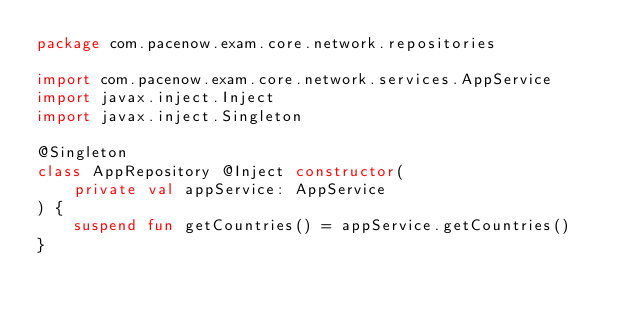Convert code to text. <code><loc_0><loc_0><loc_500><loc_500><_Kotlin_>package com.pacenow.exam.core.network.repositories

import com.pacenow.exam.core.network.services.AppService
import javax.inject.Inject
import javax.inject.Singleton

@Singleton
class AppRepository @Inject constructor(
    private val appService: AppService
) {
    suspend fun getCountries() = appService.getCountries()
}</code> 